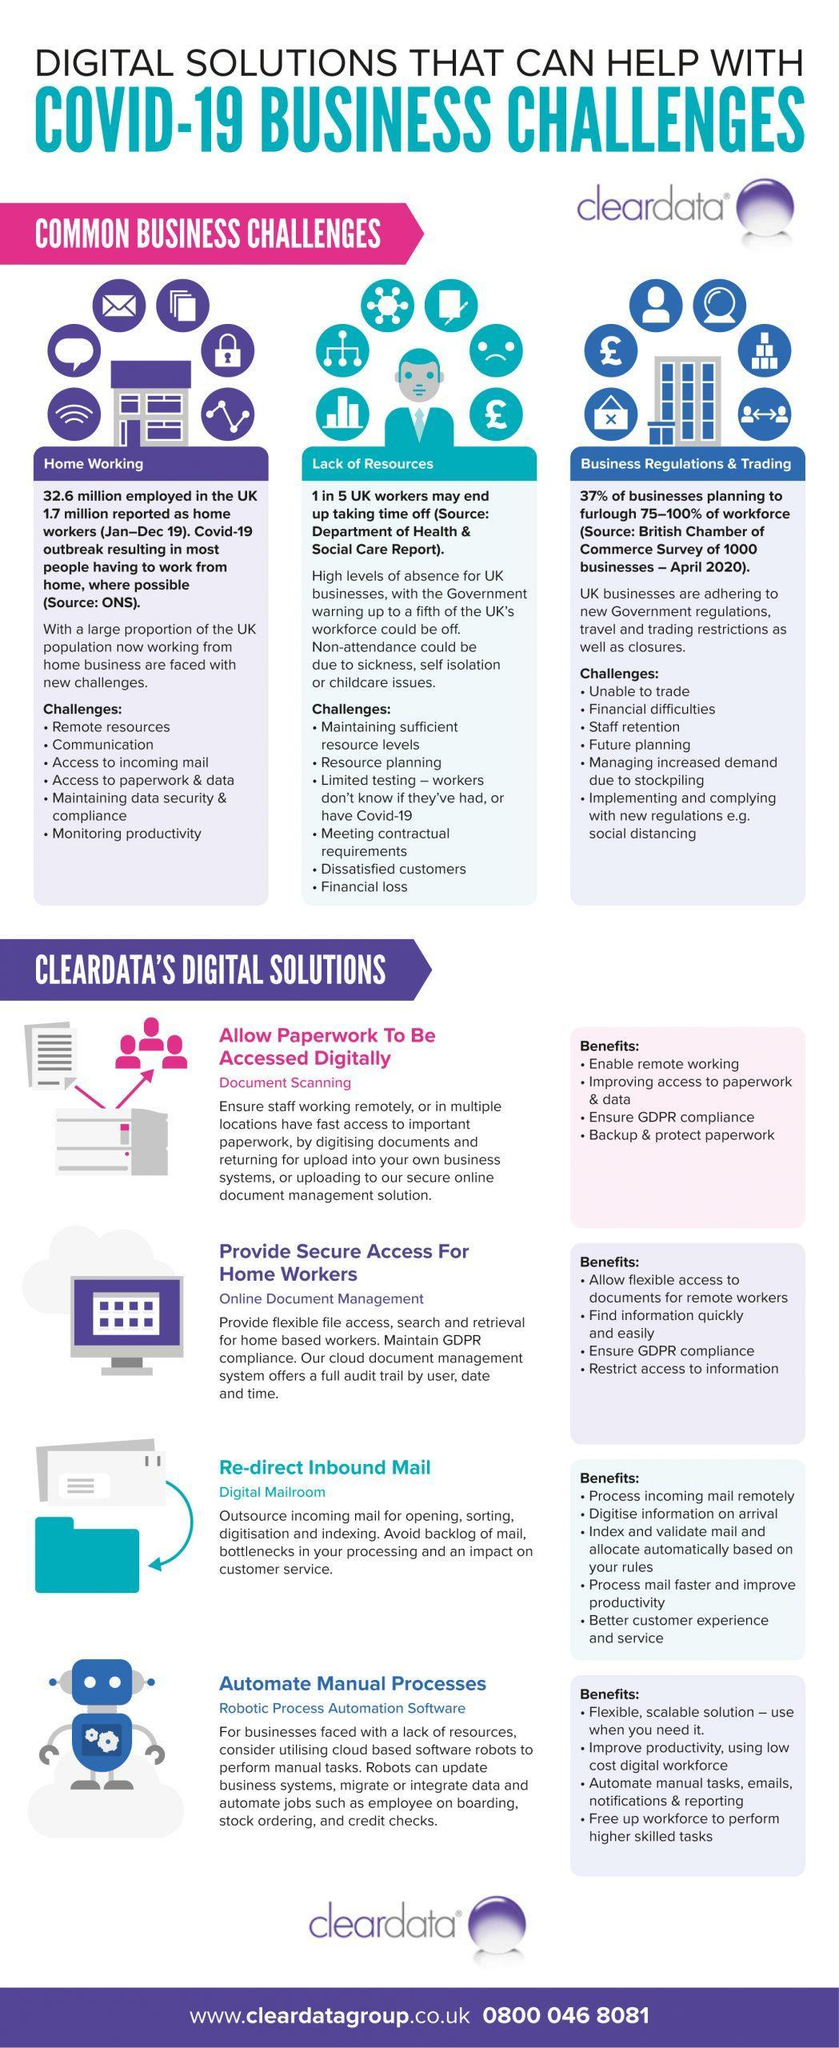What are the common business challenges?
Answer the question with a short phrase. Home working, Lack of resources, Business regulations & Trading 